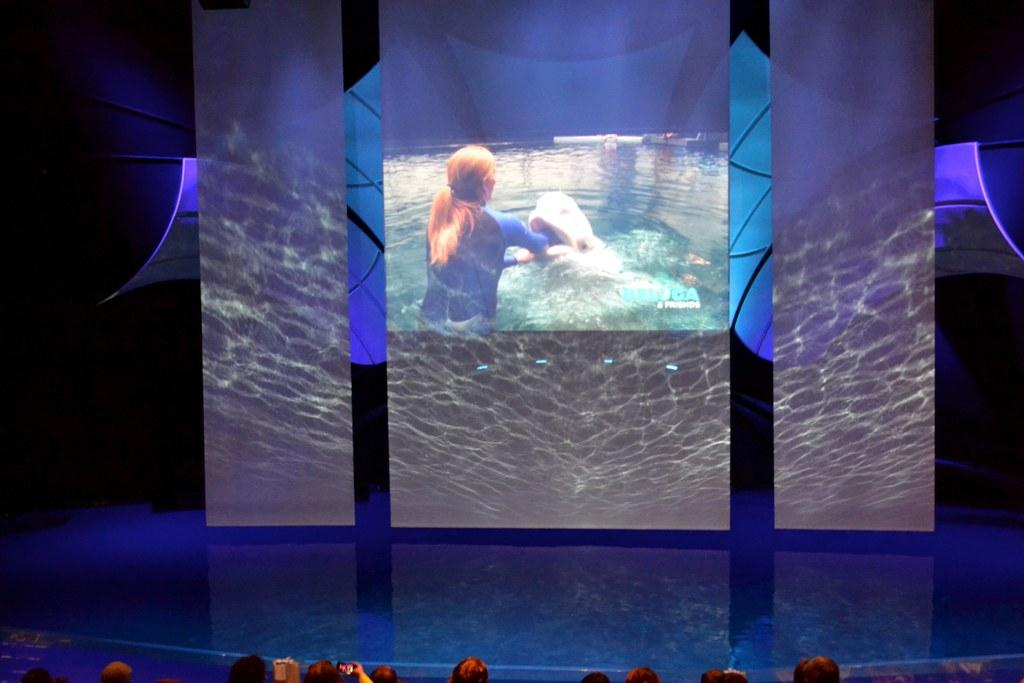What is the main object in the image? There is a screen in the image. What is being displayed on the screen? A woman in a swimming costume and a fish are visible on the screen. Are there any people present in the image? Yes, there are people in the image. How is the wool being distributed among the people in the image? There is no wool present in the image, so it cannot be distributed among the people. 